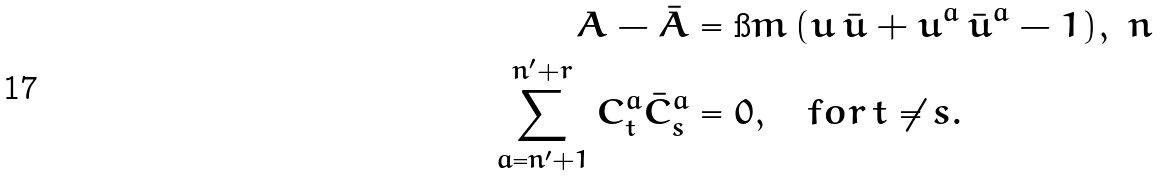<formula> <loc_0><loc_0><loc_500><loc_500>A - \bar { A } & = \i m \, ( u \, \bar { u } + u ^ { a } \, \bar { u } ^ { a } - 1 ) , \ n \\ \sum _ { a = n ^ { \prime } + 1 } ^ { n ^ { \prime } + r } C ^ { a } _ { t } \bar { C } ^ { a } _ { s } & = 0 , \quad f o r \, t \ne s .</formula> 